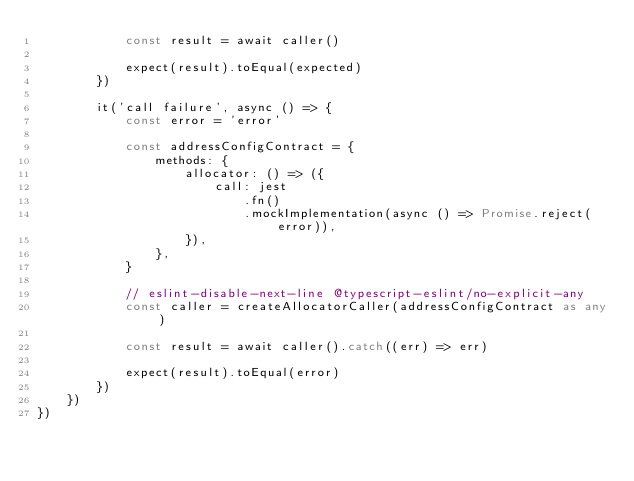Convert code to text. <code><loc_0><loc_0><loc_500><loc_500><_TypeScript_>			const result = await caller()

			expect(result).toEqual(expected)
		})

		it('call failure', async () => {
			const error = 'error'

			const addressConfigContract = {
				methods: {
					allocator: () => ({
						call: jest
							.fn()
							.mockImplementation(async () => Promise.reject(error)),
					}),
				},
			}

			// eslint-disable-next-line @typescript-eslint/no-explicit-any
			const caller = createAllocatorCaller(addressConfigContract as any)

			const result = await caller().catch((err) => err)

			expect(result).toEqual(error)
		})
	})
})
</code> 